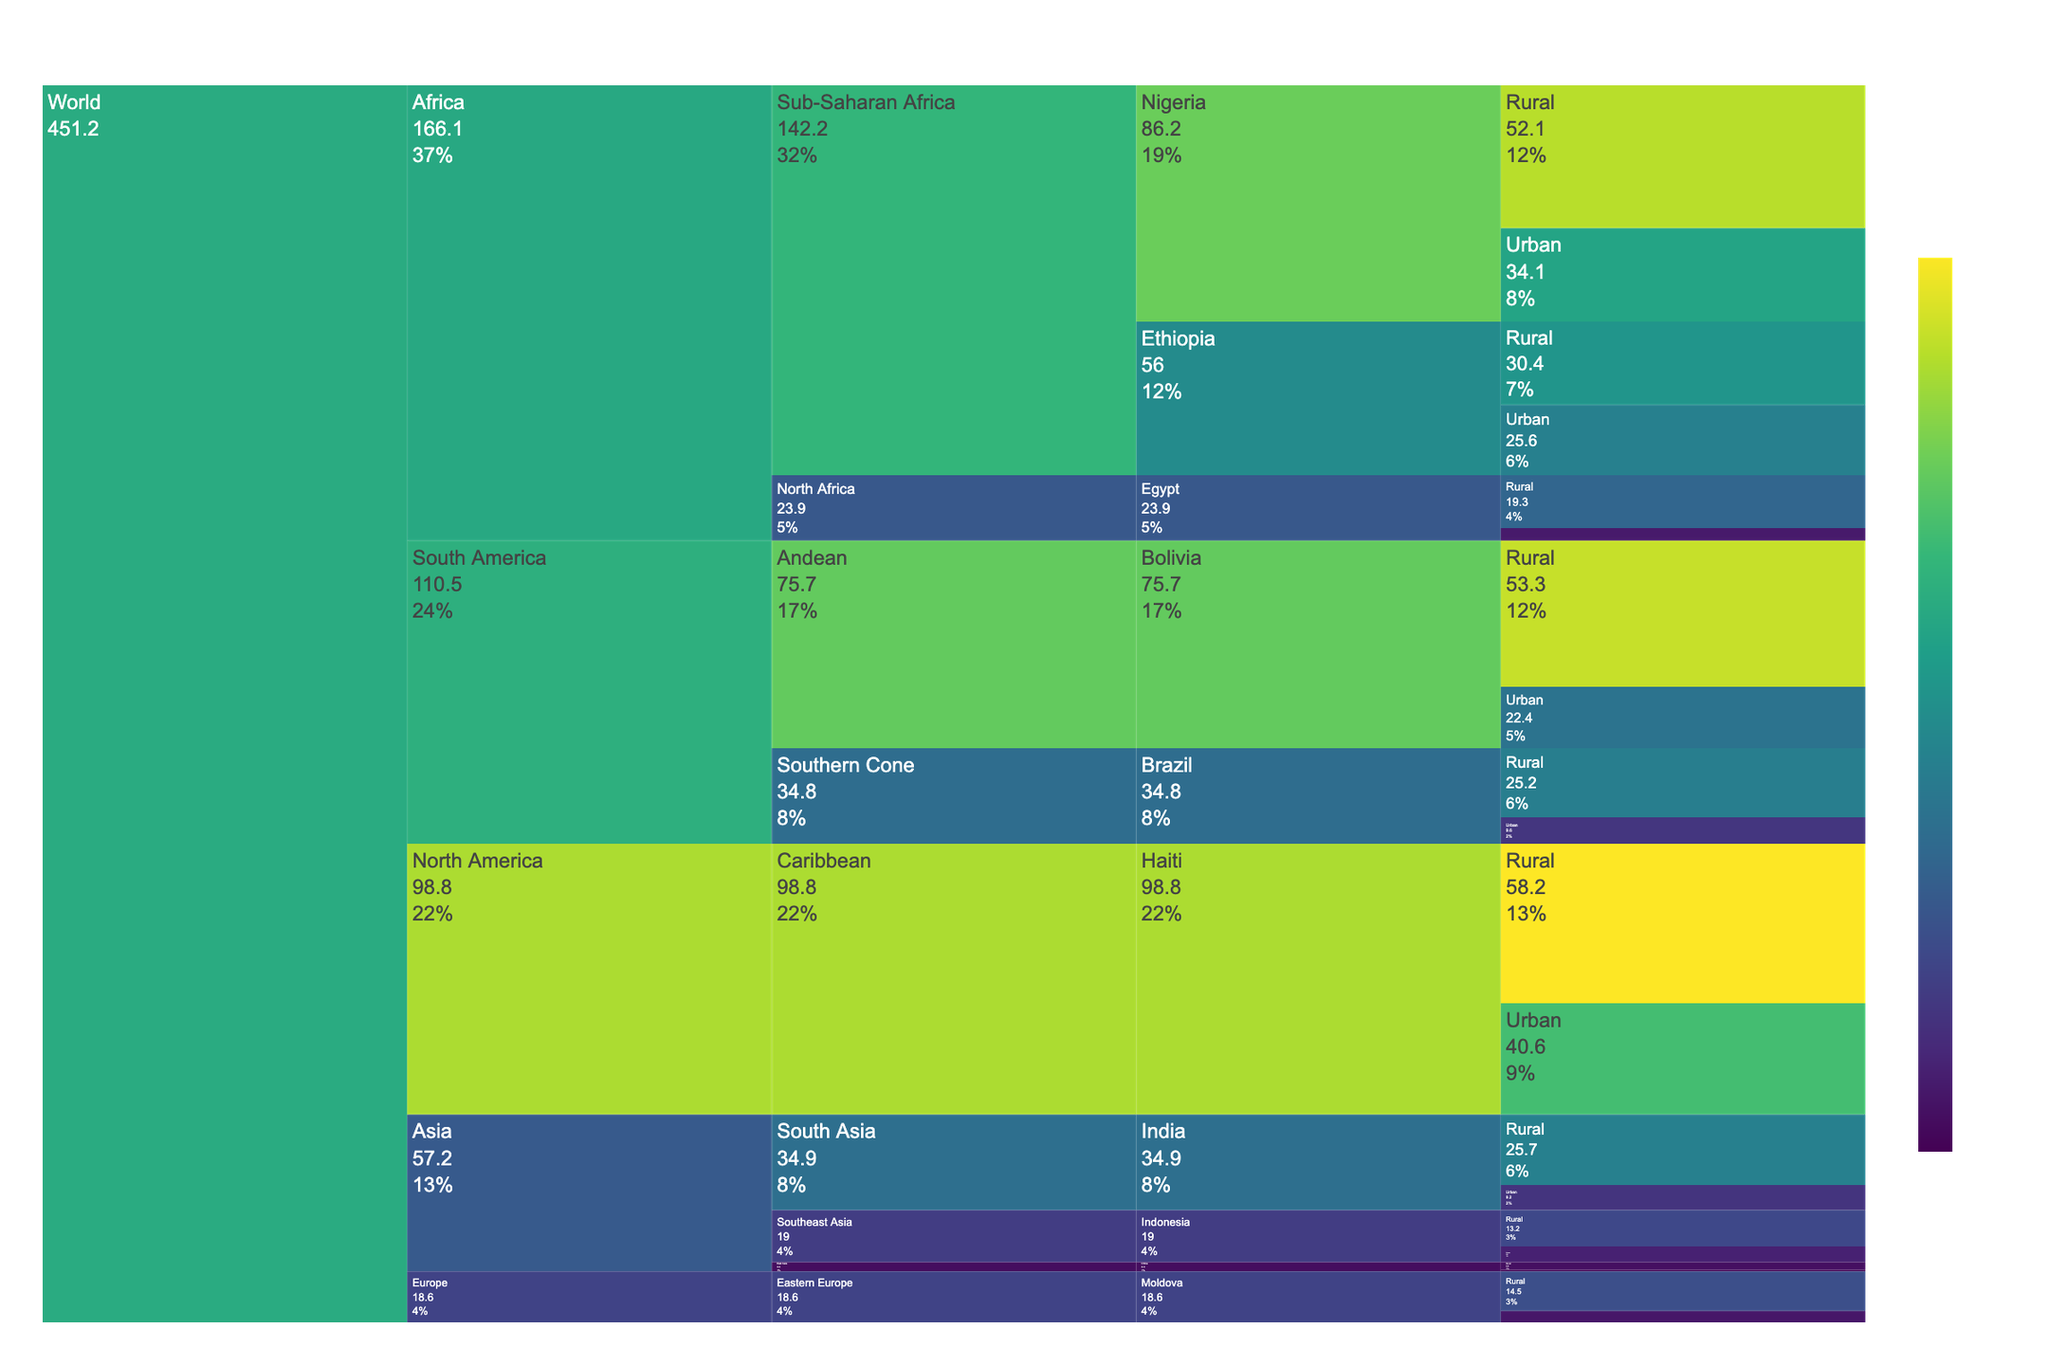Which continent has the highest urban poverty rate? Looking at the icicle chart, compare the urban areas across all continents. Identify the continent with the highest urban poverty rate among them.
Answer: North America Which country in Sub-Saharan Africa has the higher rural poverty rate? Locate the countries in Sub-Saharan Africa. Compare Nigeria and Ethiopia's rural areas' poverty rates to see which is higher.
Answer: Nigeria What is the difference in poverty rates between urban and rural areas in Egypt? Find the poverty rates for both urban and rural areas in Egypt. Subtract the urban poverty rate from the rural poverty rate to find the difference.
Answer: 14.7% Which region in Asia has the highest total poverty rate? Sum the poverty rates of the countries within each region in Asia and compare these sums to find the highest total poverty rate.
Answer: South Asia What is the average poverty rate in rural areas across all listed countries? Sum the poverty rates of all rural areas listed and divide by the number of rural data points to find the average.
Answer: 27.4% How does the poverty rate in urban China compare with rural Bolivia? Compare the poverty rates directly by looking at urban China and rural Bolivia areas in the chart.
Answer: Rural Bolivia is higher Which area in Southern Cone (South America) has the lower poverty rate? Compare urban and rural areas in the Southern Cone region by looking at Brazil's data to find the lower rate.
Answer: Urban What is the color representing the highest poverty rate in the chart? Identify the color gradient used in the chart and find the color associated with the highest value (the highest poverty rate).
Answer: Dark green What percentage of the total poverty in the Caribbean region does the rural area of Haiti represent? Find the poverty rate for rural Haiti and the total for the Caribbean region (urban + rural Haiti). Calculate the percentage of the total that the rural area represents based on these values.
Answer: 58.2% Among the listed areas, which has the lowest overall poverty rate? Identify the area (urban/rural) with the lowest numerical value across all countries and continents.
Answer: Urban China 